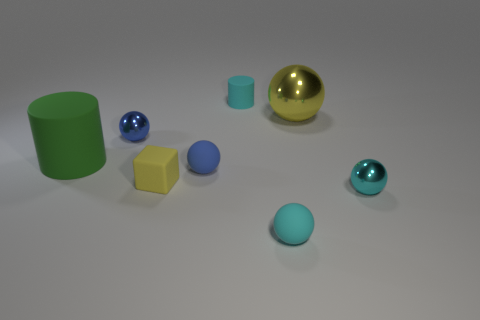Subtract all tiny cyan metallic balls. How many balls are left? 4 Subtract 1 spheres. How many spheres are left? 4 Subtract all cyan balls. How many balls are left? 3 Subtract all green balls. Subtract all purple blocks. How many balls are left? 5 Subtract all cylinders. How many objects are left? 6 Add 1 cyan matte balls. How many objects exist? 9 Add 1 large green things. How many large green things are left? 2 Add 7 cyan matte cylinders. How many cyan matte cylinders exist? 8 Subtract 1 cyan balls. How many objects are left? 7 Subtract all blue matte spheres. Subtract all small cyan matte balls. How many objects are left? 6 